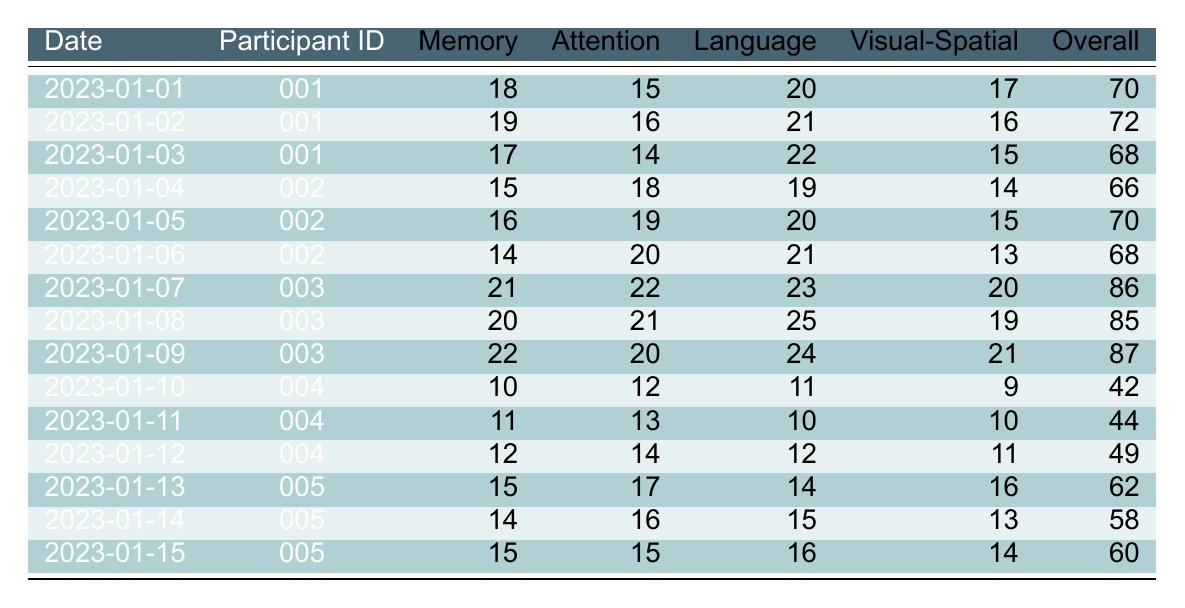What was the highest overall cognitive score recorded in the table? The overall cognitive scores are listed for different participants on different dates. Scanning the scores, the highest value is 87, recorded on 2023-01-09 for participant 003.
Answer: 87 What was the memory score of participant 002 on 2023-01-05? Looking at the row for participant 002 on 2023-01-05, the memory score is specifically stated as 16.
Answer: 16 Which day had the lowest visual-spatial score and what was the score? The visual-spatial scores for all days are compared, revealing that the lowest score is 9, recorded on 2023-01-10 for participant 004.
Answer: 9 What is the average overall cognitive score for participant 005 across the three recorded days? The overall cognitive scores for participant 005 are 62, 58, and 60. Summing these gives 62 + 58 + 60 = 180, and dividing by 3 yields an average score of 180/3 = 60.
Answer: 60 Did participant 001 perform better in language or attention on 2023-01-02? On 2023-01-02, participant 001 scored 21 in language and 16 in attention. Since 21 is greater than 16, participant 001 performed better in language.
Answer: Yes What is the difference in attention scores between participant 003 on 2023-01-07 and participant 004 on 2023-01-11? The attention score for participant 003 on 2023-01-07 is 22, while for participant 004 on 2023-01-11 it is 13. The difference is 22 - 13 = 9.
Answer: 9 Which participant had a consistently higher overall cognitive score, participant 001 or participant 002? Comparing the overall cognitive scores, participant 001 had scores of 70, 72, and 68 (average of 70), whereas participant 002 had scores of 66, 70, and 68 (average of 68). Thus, participant 001 had a higher average overall cognitive score.
Answer: Participant 001 What were the memory scores for participant 004 over the recorded days, and what trend can be identified? Participant 004's memory scores are 10, 11, and 12 over three days. This shows a consistent increase of 1 point each day, indicating an upward trend.
Answer: Upward trend How does participant 005's attention score on 2023-01-13 compare to their score on 2023-01-15? The attention scores for participant 005 are 17 on 2023-01-13 and 15 on 2023-01-15. Comparing these, 17 is higher than 15, indicating a performance decrease in attention between these days.
Answer: Decrease Was there a day when participant 002 scored higher in memory than in attention? Reviewing the scores for participant 002, on 2023-01-05, memory was 16 and attention was 19. Since 16 is not higher than 19, the answer would be examined across other days. On 2023-01-06, the memory score was 14 and attention was 20. Both days show memory scores lower than attention. Therefore, the answer is no.
Answer: No 